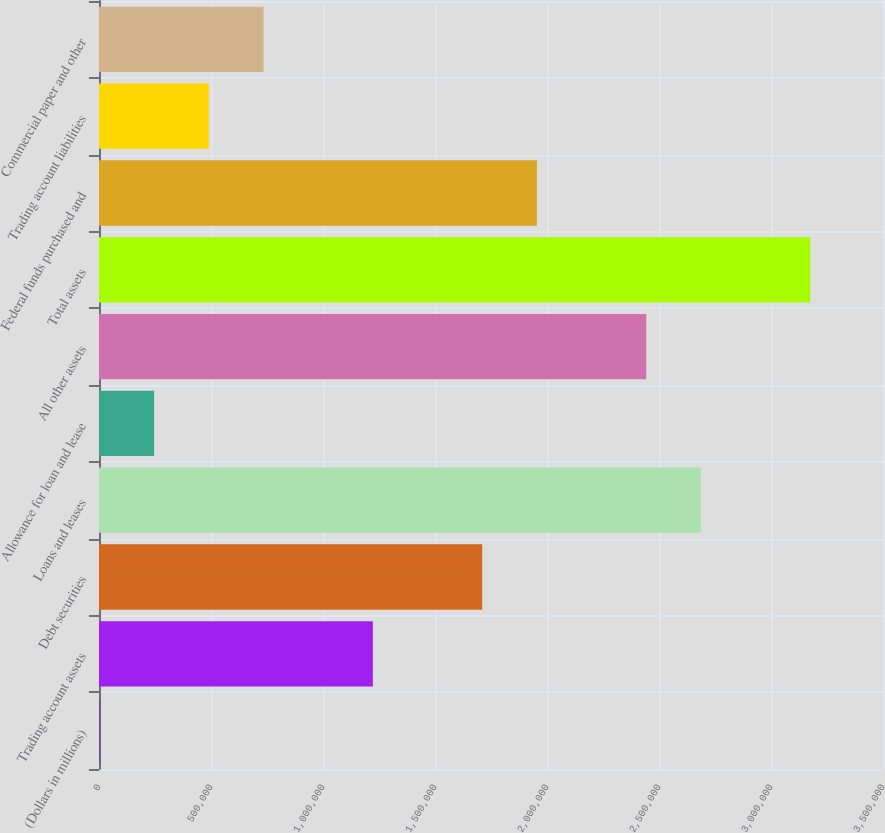Convert chart. <chart><loc_0><loc_0><loc_500><loc_500><bar_chart><fcel>(Dollars in millions)<fcel>Trading account assets<fcel>Debt securities<fcel>Loans and leases<fcel>Allowance for loan and lease<fcel>All other assets<fcel>Total assets<fcel>Federal funds purchased and<fcel>Trading account liabilities<fcel>Commercial paper and other<nl><fcel>2009<fcel>1.22254e+06<fcel>1.71075e+06<fcel>2.68717e+06<fcel>246115<fcel>2.44307e+06<fcel>3.17539e+06<fcel>1.95486e+06<fcel>490221<fcel>734327<nl></chart> 